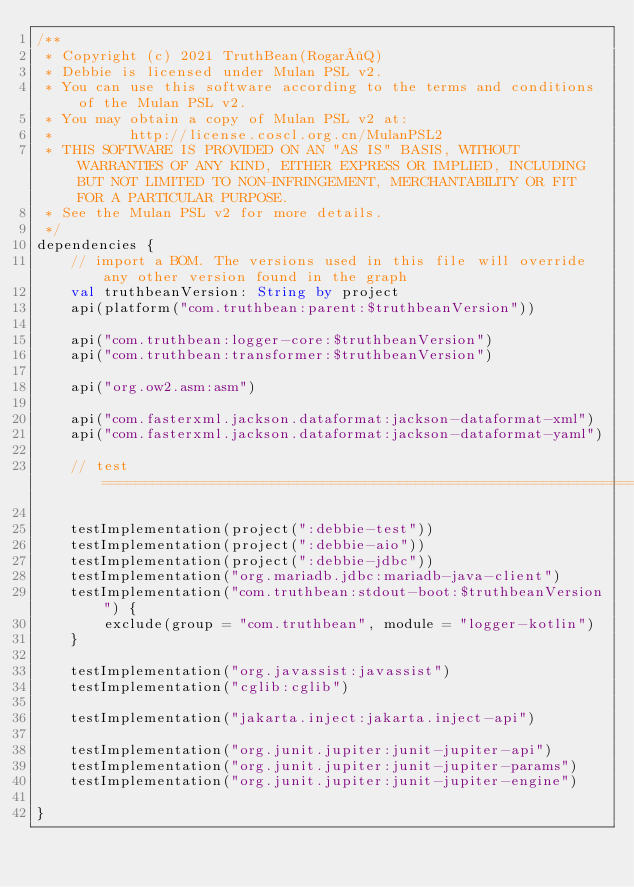Convert code to text. <code><loc_0><loc_0><loc_500><loc_500><_Kotlin_>/**
 * Copyright (c) 2021 TruthBean(Rogar·Q)
 * Debbie is licensed under Mulan PSL v2.
 * You can use this software according to the terms and conditions of the Mulan PSL v2.
 * You may obtain a copy of Mulan PSL v2 at:
 *         http://license.coscl.org.cn/MulanPSL2
 * THIS SOFTWARE IS PROVIDED ON AN "AS IS" BASIS, WITHOUT WARRANTIES OF ANY KIND, EITHER EXPRESS OR IMPLIED, INCLUDING BUT NOT LIMITED TO NON-INFRINGEMENT, MERCHANTABILITY OR FIT FOR A PARTICULAR PURPOSE.
 * See the Mulan PSL v2 for more details.
 */
dependencies {
    // import a BOM. The versions used in this file will override any other version found in the graph
    val truthbeanVersion: String by project
    api(platform("com.truthbean:parent:$truthbeanVersion"))

    api("com.truthbean:logger-core:$truthbeanVersion")
    api("com.truthbean:transformer:$truthbeanVersion")

    api("org.ow2.asm:asm")

    api("com.fasterxml.jackson.dataformat:jackson-dataformat-xml")
    api("com.fasterxml.jackson.dataformat:jackson-dataformat-yaml")

    // test =========================================================================================================

    testImplementation(project(":debbie-test"))
    testImplementation(project(":debbie-aio"))
    testImplementation(project(":debbie-jdbc"))
    testImplementation("org.mariadb.jdbc:mariadb-java-client")
    testImplementation("com.truthbean:stdout-boot:$truthbeanVersion") {
        exclude(group = "com.truthbean", module = "logger-kotlin")
    }

    testImplementation("org.javassist:javassist")
    testImplementation("cglib:cglib")

    testImplementation("jakarta.inject:jakarta.inject-api")

    testImplementation("org.junit.jupiter:junit-jupiter-api")
    testImplementation("org.junit.jupiter:junit-jupiter-params")
    testImplementation("org.junit.jupiter:junit-jupiter-engine")

}
</code> 